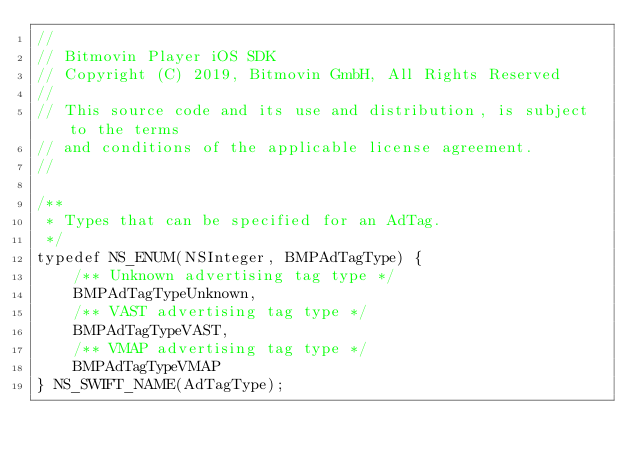<code> <loc_0><loc_0><loc_500><loc_500><_C_>//
// Bitmovin Player iOS SDK
// Copyright (C) 2019, Bitmovin GmbH, All Rights Reserved
//
// This source code and its use and distribution, is subject to the terms
// and conditions of the applicable license agreement.
//

/**
 * Types that can be specified for an AdTag.
 */
typedef NS_ENUM(NSInteger, BMPAdTagType) {
    /** Unknown advertising tag type */
    BMPAdTagTypeUnknown,
    /** VAST advertising tag type */
    BMPAdTagTypeVAST,
    /** VMAP advertising tag type */
    BMPAdTagTypeVMAP
} NS_SWIFT_NAME(AdTagType);
</code> 